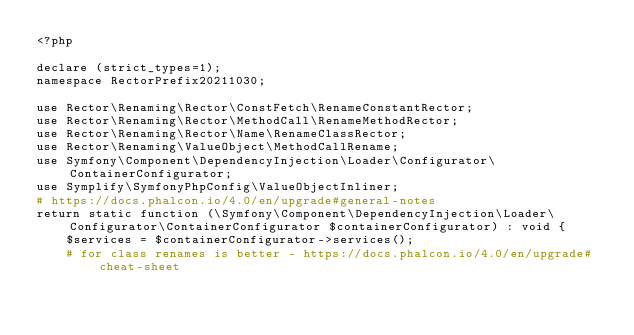Convert code to text. <code><loc_0><loc_0><loc_500><loc_500><_PHP_><?php

declare (strict_types=1);
namespace RectorPrefix20211030;

use Rector\Renaming\Rector\ConstFetch\RenameConstantRector;
use Rector\Renaming\Rector\MethodCall\RenameMethodRector;
use Rector\Renaming\Rector\Name\RenameClassRector;
use Rector\Renaming\ValueObject\MethodCallRename;
use Symfony\Component\DependencyInjection\Loader\Configurator\ContainerConfigurator;
use Symplify\SymfonyPhpConfig\ValueObjectInliner;
# https://docs.phalcon.io/4.0/en/upgrade#general-notes
return static function (\Symfony\Component\DependencyInjection\Loader\Configurator\ContainerConfigurator $containerConfigurator) : void {
    $services = $containerConfigurator->services();
    # for class renames is better - https://docs.phalcon.io/4.0/en/upgrade#cheat-sheet</code> 